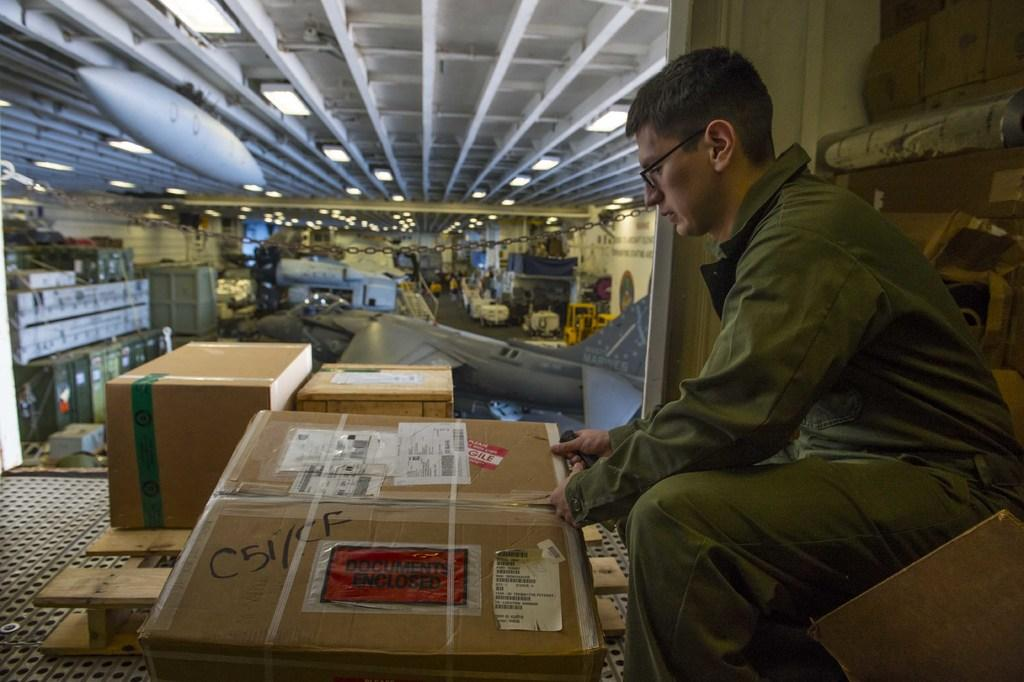<image>
Create a compact narrative representing the image presented. The package in front claims to have documents enclosed. 